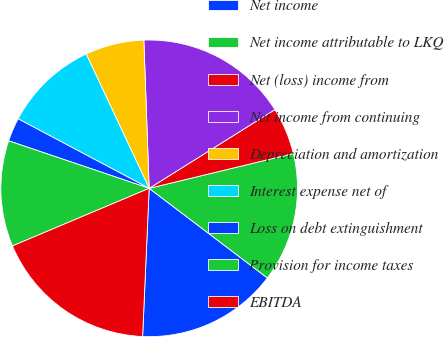<chart> <loc_0><loc_0><loc_500><loc_500><pie_chart><fcel>Net income<fcel>Net income attributable to LKQ<fcel>Net (loss) income from<fcel>Net income from continuing<fcel>Depreciation and amortization<fcel>Interest expense net of<fcel>Loss on debt extinguishment<fcel>Provision for income taxes<fcel>EBITDA<nl><fcel>15.38%<fcel>14.1%<fcel>5.13%<fcel>16.67%<fcel>6.41%<fcel>10.26%<fcel>2.57%<fcel>11.54%<fcel>17.95%<nl></chart> 